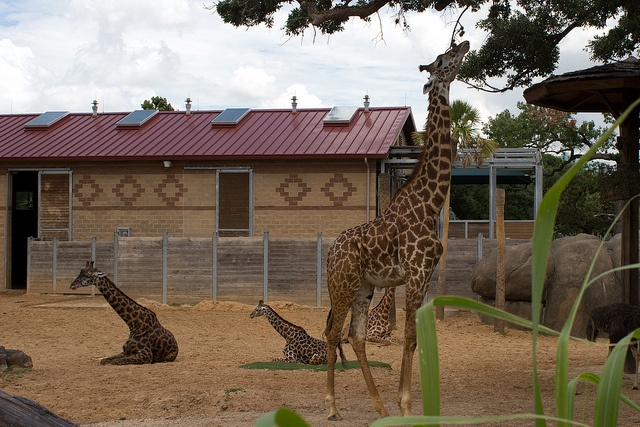Describe the objects in this image and their specific colors. I can see giraffe in lavender, maroon, black, and gray tones, giraffe in lavender, black, maroon, and gray tones, giraffe in lavender, black, gray, and maroon tones, and giraffe in lavender, maroon, black, and gray tones in this image. 